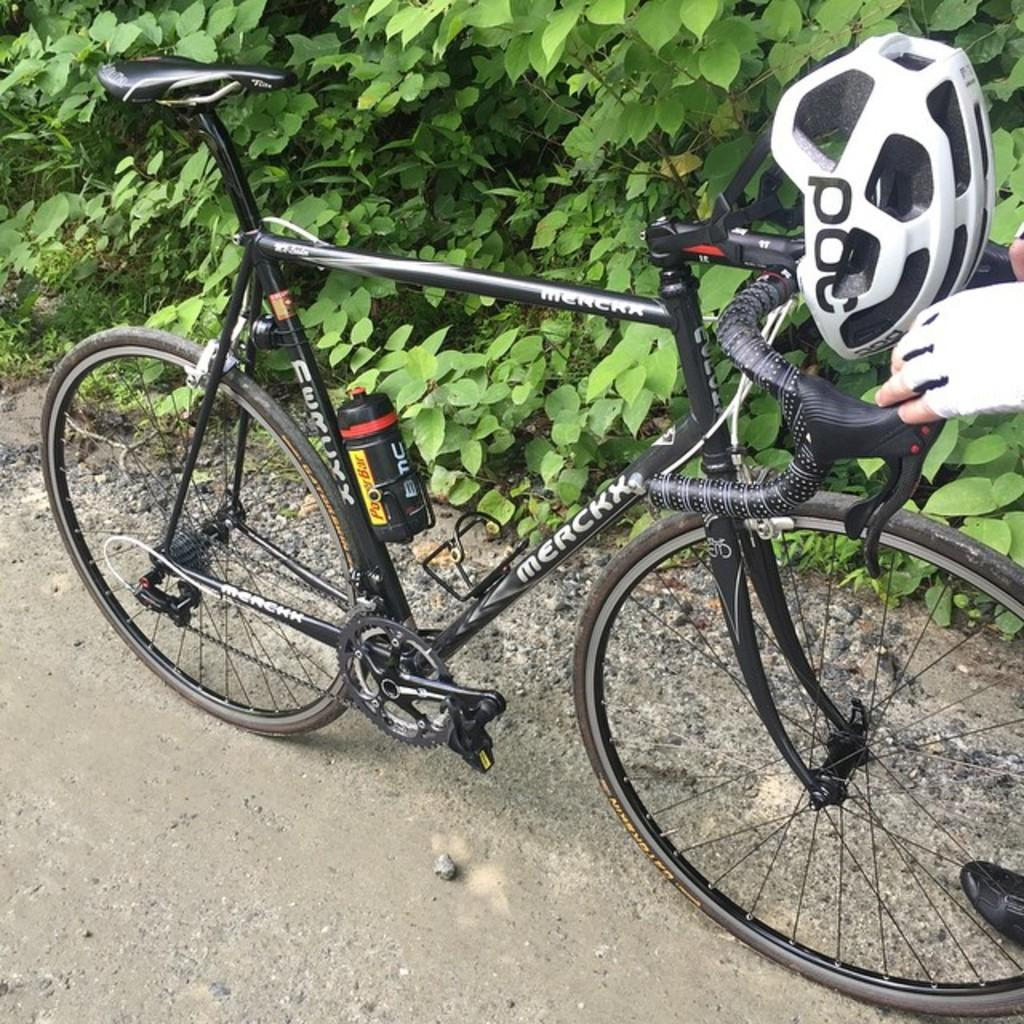What color is the bicycle in the image? The bicycle is black in color. Where is the bicycle located in the image? The bicycle is on the road. Who is holding the bicycle in the image? A person's hands are holding the bicycle on the right side. What can be seen in the background of the image? There are plants visible in the background of the image. What type of pear is being used as a prop in the image? There is no pear present in the image. What action is the person taking with the bicycle in the image? The person's hands are holding the bicycle, but we cannot determine any specific action from the image. 